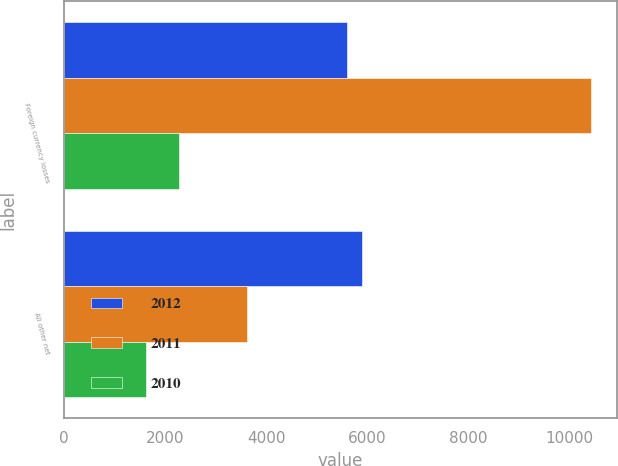Convert chart. <chart><loc_0><loc_0><loc_500><loc_500><stacked_bar_chart><ecel><fcel>Foreign currency losses<fcel>All other net<nl><fcel>2012<fcel>5599<fcel>5902<nl><fcel>2011<fcel>10423<fcel>3628<nl><fcel>2010<fcel>2270<fcel>1630<nl></chart> 